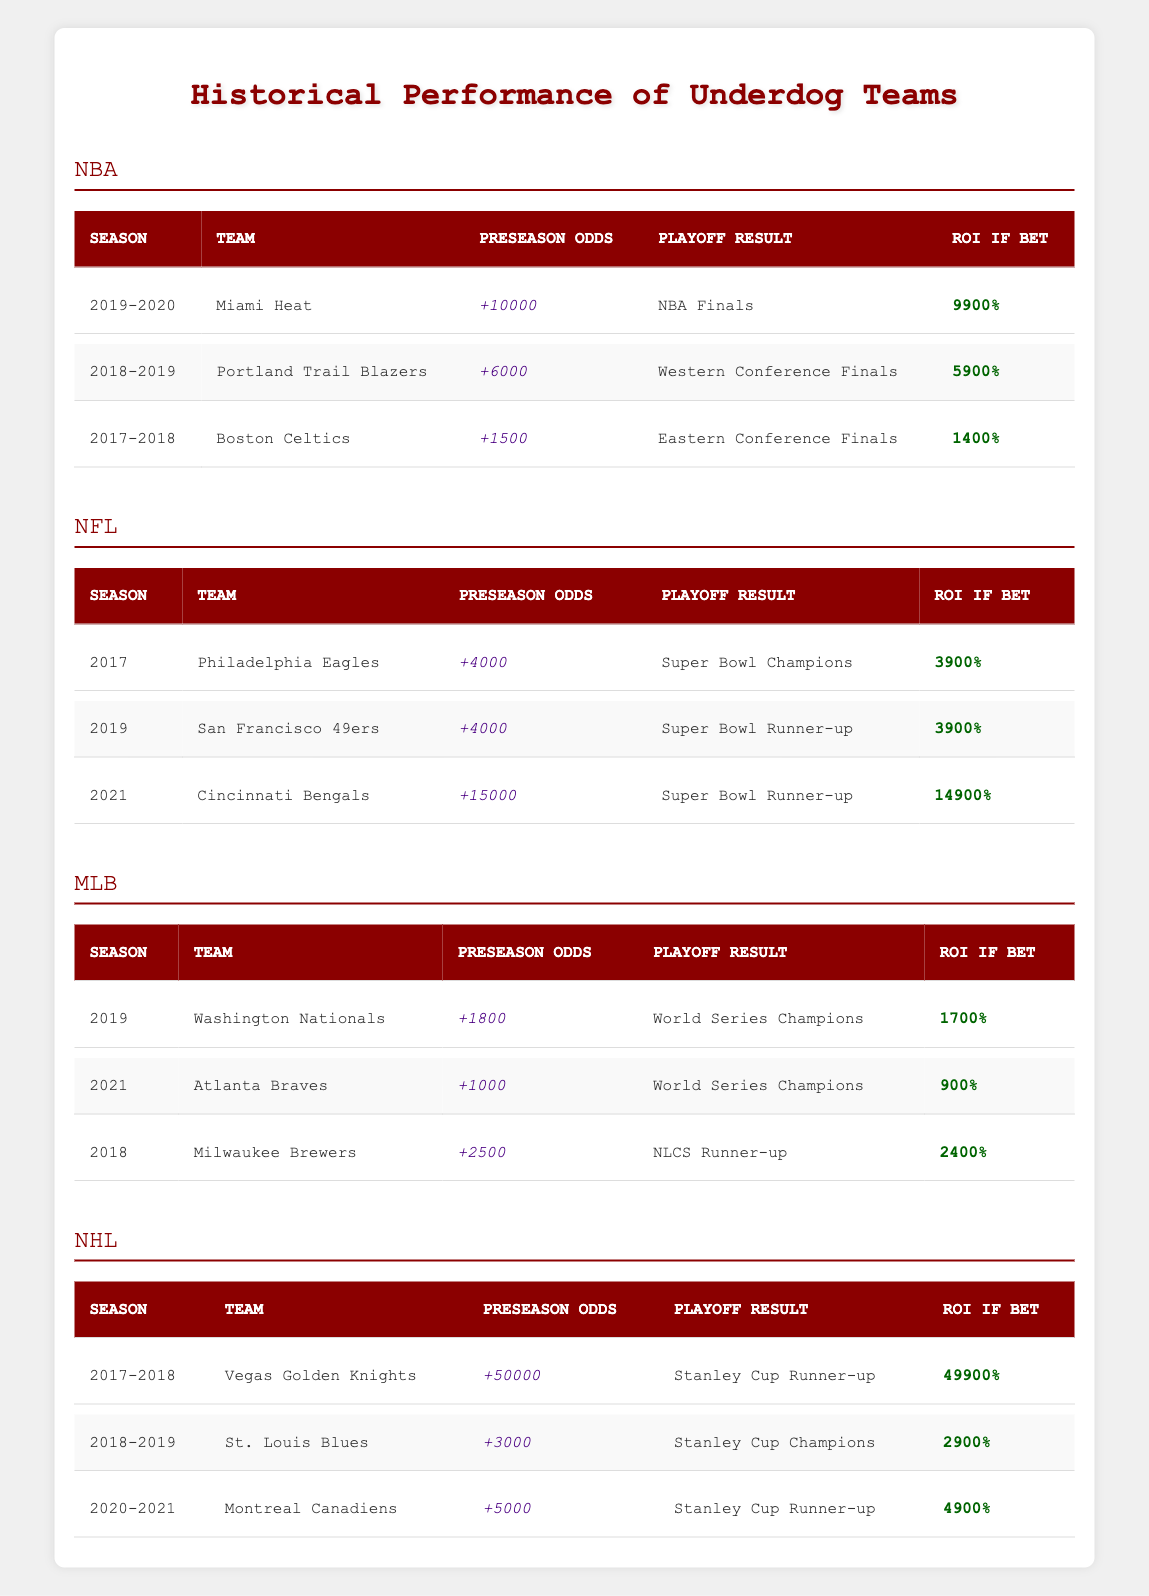What were the preseason odds for the Miami Heat in the 2019-2020 season? The table under the NBA section lists the Miami Heat's preseason odds as +10000 for the 2019-2020 season.
Answer: +10000 How many teams reached the NBA Finals among underdogs listed in the table? The NBA table shows the Miami Heat (2019-2020) reaching the NBA Finals. Therefore, there is one team.
Answer: 1 Which NFL team had the highest ROI if bet? In the NFL section, the Cincinnati Bengals in 2021 show an ROI of 14900%, which is the highest among all entries in the NFL column.
Answer: 14900% What is the average ROI of the MLB teams listed in the table? The ROI values for the MLB teams are 1700%, 900%, and 2400%. Adding these gives 1700 + 900 + 2400 = 5000. Dividing by the three teams gives an average of 5000 / 3 = 1666.67%.
Answer: 1666.67% Did any NHL team listed below win the Stanley Cup? The NHL table shows that the St. Louis Blues in the 2018-2019 season won the Stanley Cup, confirming the fact.
Answer: Yes Which underdog team had the lowest preseason odds, and what was that value? Examining the data, the team with the lowest preseason odds is the Atlanta Braves at +1000 in the MLB section.
Answer: +1000 How many underdog teams reached their respective league finals in the data provided? In the NBA, the Miami Heat reached the Finals; in the NFL, the Philadelphia Eagles won the Super Bowl, and the San Francisco 49ers were runners-up. In the NHL, the St. Louis Blues won the Cup and the Montreal Canadiens were the runner-up. There are five teams total that reached their championship series.
Answer: 5 Which season had the highest ROI among all sports leagues combined? The Cincinnati Bengals have the highest ROI of 14900% from the NFL section. No other team reached or exceeded this ROI in the other leagues, confirming it's the highest across all leagues combined.
Answer: 14900% For how many seasons did the underdog teams listed not win their playoff series? Reviewing the data, the Boston Celtics, San Francisco 49ers, Milwaukee Brewers, and Montreal Canadiens did not win their respective playoffs, totaling four seasons.
Answer: 4 